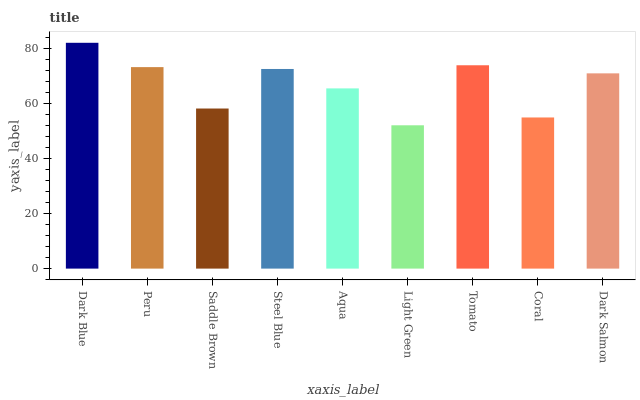Is Light Green the minimum?
Answer yes or no. Yes. Is Dark Blue the maximum?
Answer yes or no. Yes. Is Peru the minimum?
Answer yes or no. No. Is Peru the maximum?
Answer yes or no. No. Is Dark Blue greater than Peru?
Answer yes or no. Yes. Is Peru less than Dark Blue?
Answer yes or no. Yes. Is Peru greater than Dark Blue?
Answer yes or no. No. Is Dark Blue less than Peru?
Answer yes or no. No. Is Dark Salmon the high median?
Answer yes or no. Yes. Is Dark Salmon the low median?
Answer yes or no. Yes. Is Tomato the high median?
Answer yes or no. No. Is Dark Blue the low median?
Answer yes or no. No. 